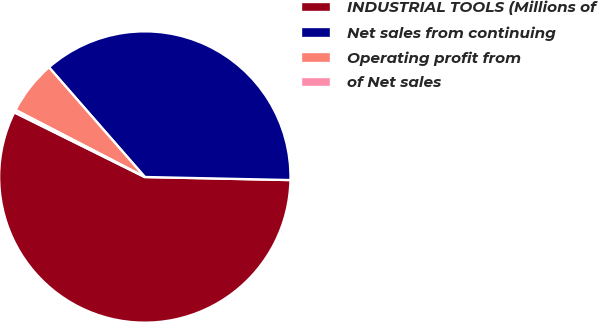Convert chart to OTSL. <chart><loc_0><loc_0><loc_500><loc_500><pie_chart><fcel>INDUSTRIAL TOOLS (Millions of<fcel>Net sales from continuing<fcel>Operating profit from<fcel>of Net sales<nl><fcel>56.98%<fcel>36.76%<fcel>5.96%<fcel>0.29%<nl></chart> 